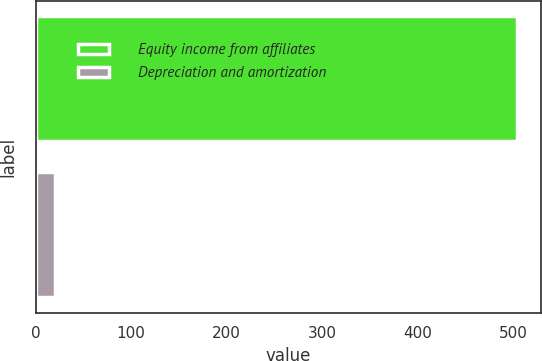<chart> <loc_0><loc_0><loc_500><loc_500><bar_chart><fcel>Equity income from affiliates<fcel>Depreciation and amortization<nl><fcel>504<fcel>20<nl></chart> 